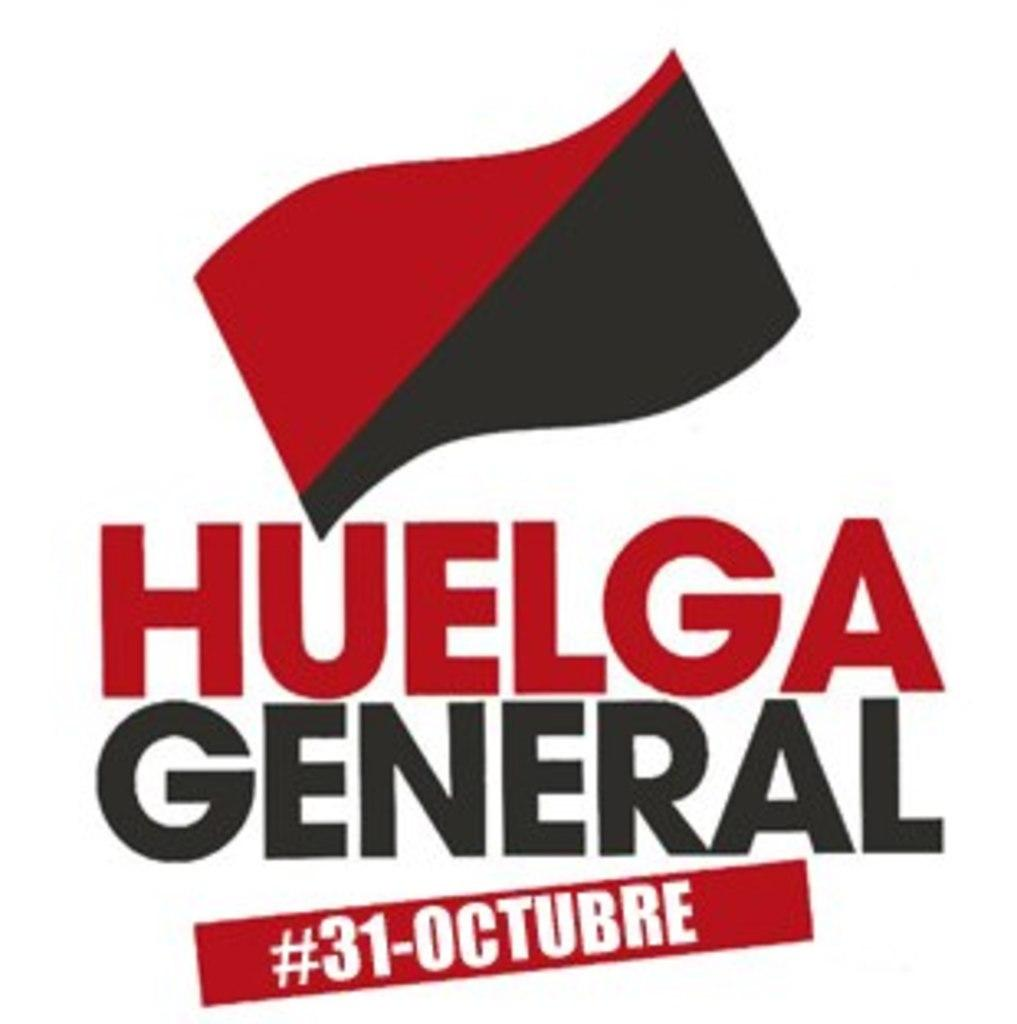<image>
Give a short and clear explanation of the subsequent image. A flyer with a red and brown flag titled Huelga General. 